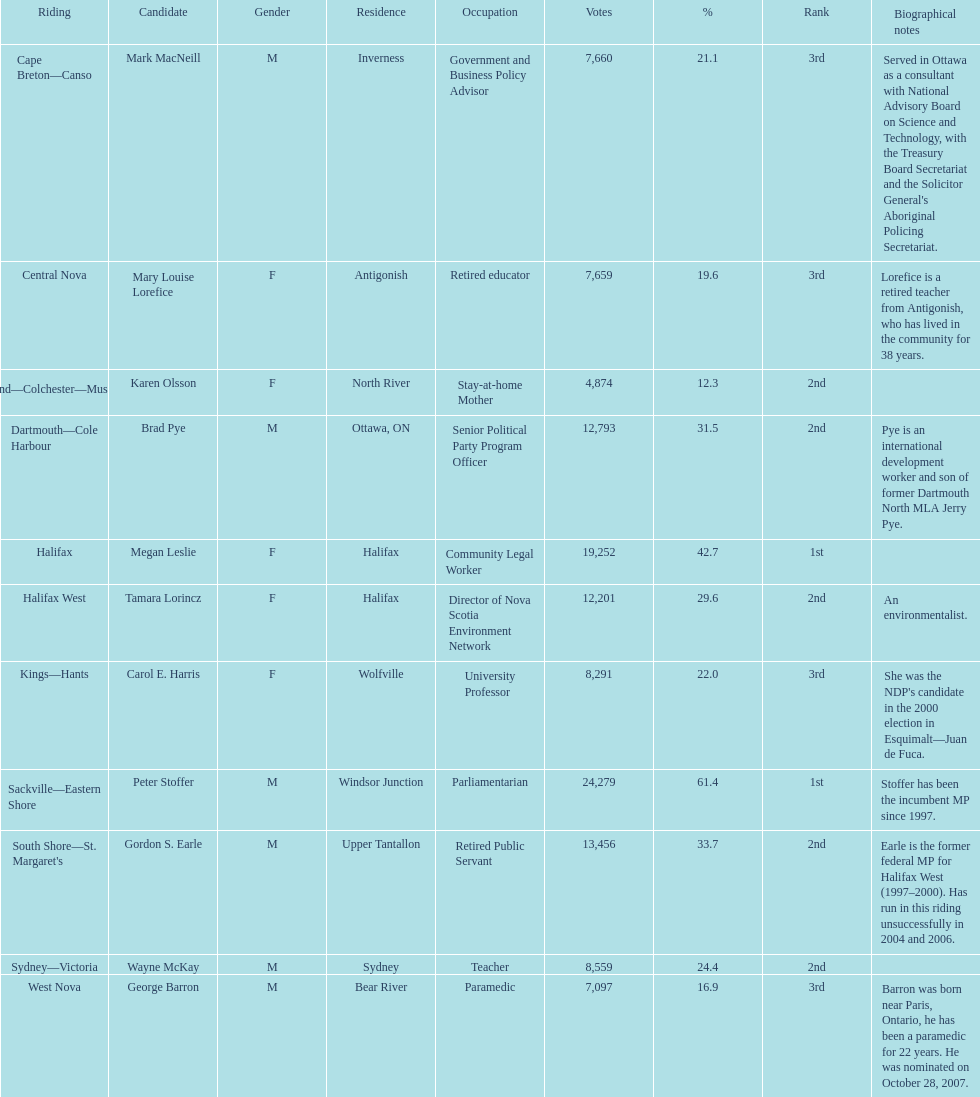Who garnered more votes, macneill or olsson? Mark MacNeill. 